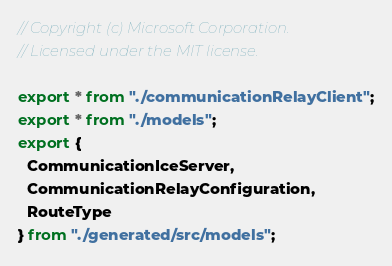Convert code to text. <code><loc_0><loc_0><loc_500><loc_500><_TypeScript_>// Copyright (c) Microsoft Corporation.
// Licensed under the MIT license.

export * from "./communicationRelayClient";
export * from "./models";
export {
  CommunicationIceServer,
  CommunicationRelayConfiguration,
  RouteType
} from "./generated/src/models";
</code> 